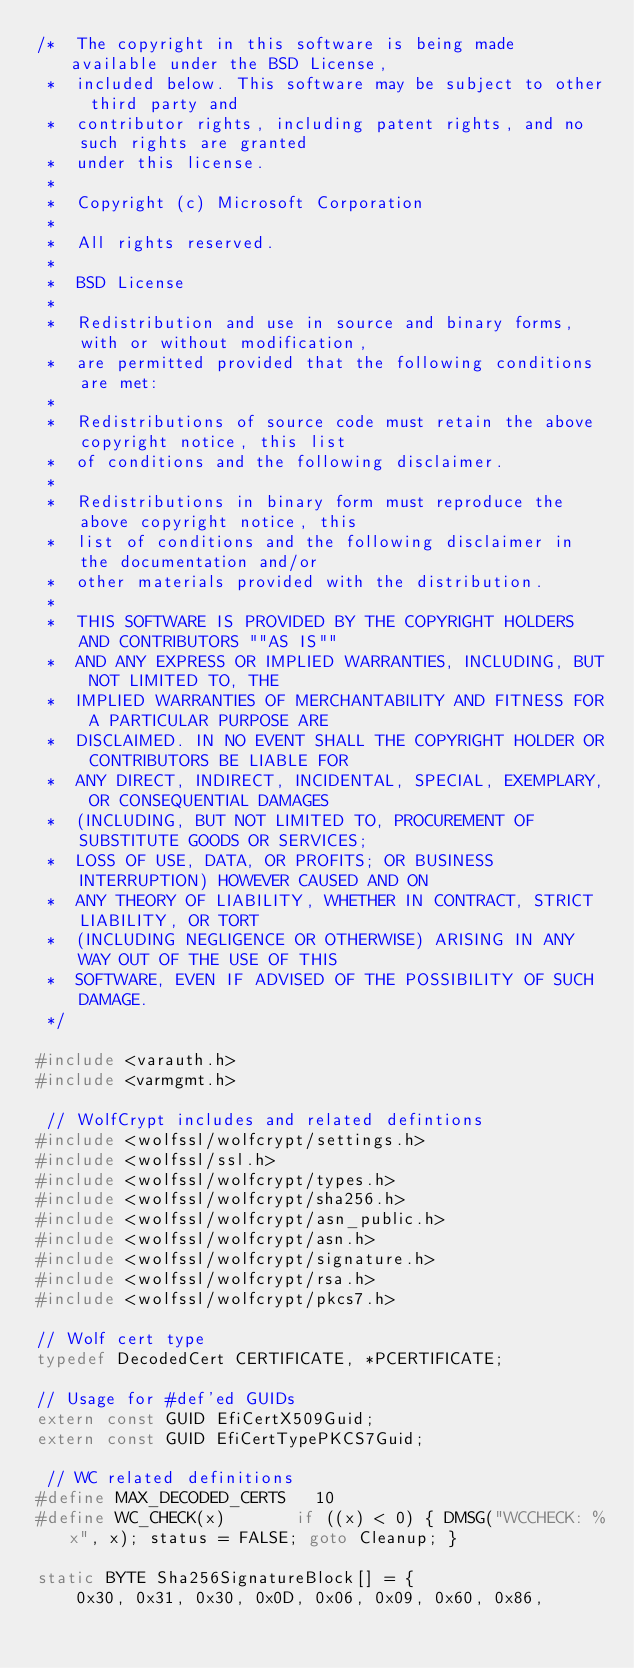<code> <loc_0><loc_0><loc_500><loc_500><_C_>/*  The copyright in this software is being made available under the BSD License,
 *  included below. This software may be subject to other third party and
 *  contributor rights, including patent rights, and no such rights are granted
 *  under this license.
 *
 *  Copyright (c) Microsoft Corporation
 *
 *  All rights reserved.
 *
 *  BSD License
 *
 *  Redistribution and use in source and binary forms, with or without modification,
 *  are permitted provided that the following conditions are met:
 *
 *  Redistributions of source code must retain the above copyright notice, this list
 *  of conditions and the following disclaimer.
 *
 *  Redistributions in binary form must reproduce the above copyright notice, this
 *  list of conditions and the following disclaimer in the documentation and/or
 *  other materials provided with the distribution.
 *
 *  THIS SOFTWARE IS PROVIDED BY THE COPYRIGHT HOLDERS AND CONTRIBUTORS ""AS IS""
 *  AND ANY EXPRESS OR IMPLIED WARRANTIES, INCLUDING, BUT NOT LIMITED TO, THE
 *  IMPLIED WARRANTIES OF MERCHANTABILITY AND FITNESS FOR A PARTICULAR PURPOSE ARE
 *  DISCLAIMED. IN NO EVENT SHALL THE COPYRIGHT HOLDER OR CONTRIBUTORS BE LIABLE FOR
 *  ANY DIRECT, INDIRECT, INCIDENTAL, SPECIAL, EXEMPLARY, OR CONSEQUENTIAL DAMAGES
 *  (INCLUDING, BUT NOT LIMITED TO, PROCUREMENT OF SUBSTITUTE GOODS OR SERVICES;
 *  LOSS OF USE, DATA, OR PROFITS; OR BUSINESS INTERRUPTION) HOWEVER CAUSED AND ON
 *  ANY THEORY OF LIABILITY, WHETHER IN CONTRACT, STRICT LIABILITY, OR TORT
 *  (INCLUDING NEGLIGENCE OR OTHERWISE) ARISING IN ANY WAY OUT OF THE USE OF THIS
 *  SOFTWARE, EVEN IF ADVISED OF THE POSSIBILITY OF SUCH DAMAGE.
 */

#include <varauth.h>
#include <varmgmt.h>

 // WolfCrypt includes and related defintions
#include <wolfssl/wolfcrypt/settings.h>
#include <wolfssl/ssl.h>
#include <wolfssl/wolfcrypt/types.h>
#include <wolfssl/wolfcrypt/sha256.h>
#include <wolfssl/wolfcrypt/asn_public.h>
#include <wolfssl/wolfcrypt/asn.h>
#include <wolfssl/wolfcrypt/signature.h>
#include <wolfssl/wolfcrypt/rsa.h>
#include <wolfssl/wolfcrypt/pkcs7.h>

// Wolf cert type
typedef DecodedCert CERTIFICATE, *PCERTIFICATE;

// Usage for #def'ed GUIDs
extern const GUID EfiCertX509Guid;
extern const GUID EfiCertTypePKCS7Guid;

 // WC related definitions
#define MAX_DECODED_CERTS   10
#define WC_CHECK(x)       if ((x) < 0) { DMSG("WCCHECK: %x", x); status = FALSE; goto Cleanup; }

static BYTE Sha256SignatureBlock[] = {
    0x30, 0x31, 0x30, 0x0D, 0x06, 0x09, 0x60, 0x86,</code> 